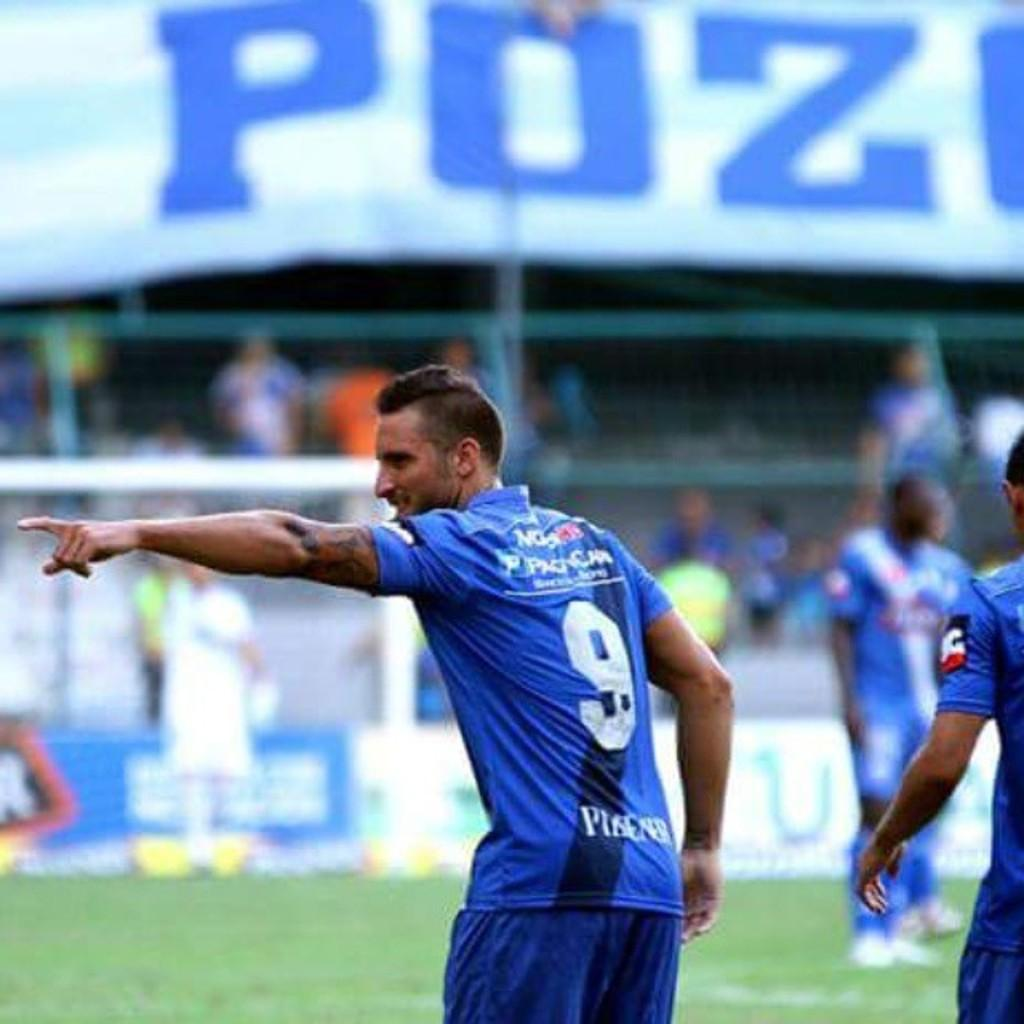Provide a one-sentence caption for the provided image. a man in a blue jersey, number 9, is pointing to the crowd. 